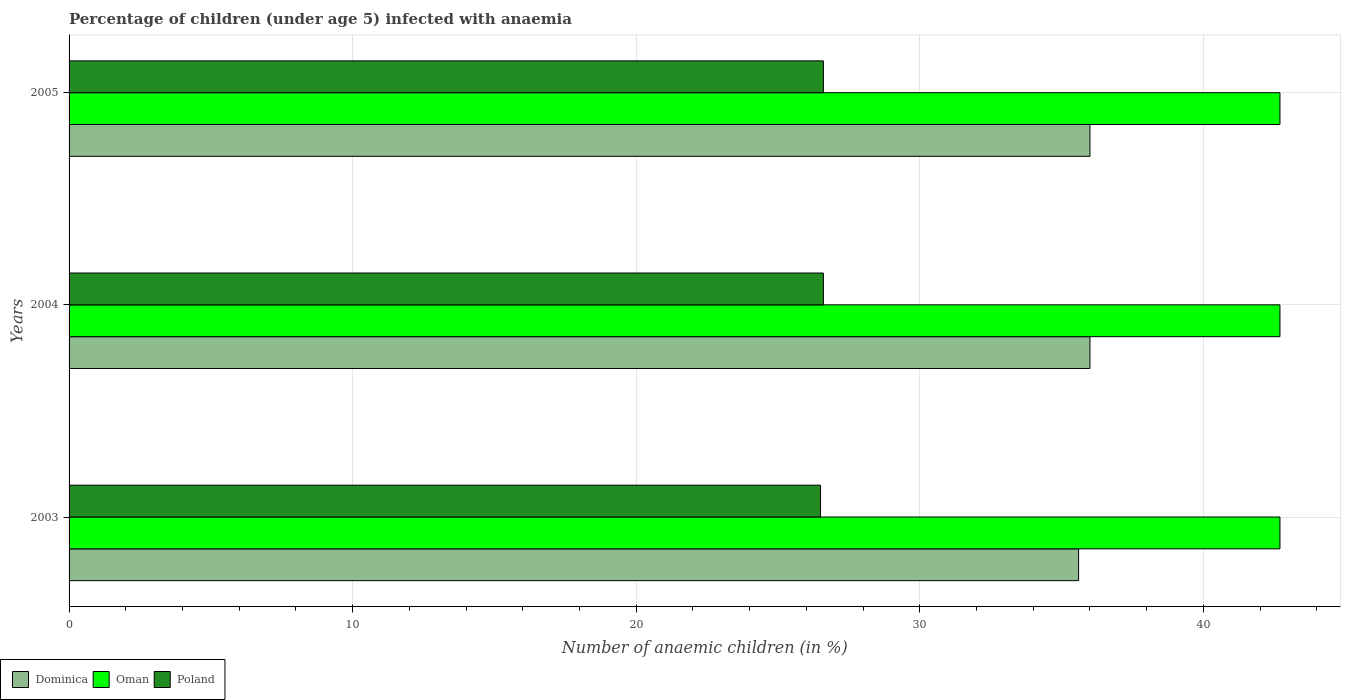Are the number of bars per tick equal to the number of legend labels?
Ensure brevity in your answer.  Yes. How many bars are there on the 3rd tick from the bottom?
Your response must be concise. 3. What is the label of the 3rd group of bars from the top?
Offer a terse response. 2003. In how many cases, is the number of bars for a given year not equal to the number of legend labels?
Provide a succinct answer. 0. Across all years, what is the maximum percentage of children infected with anaemia in in Oman?
Make the answer very short. 42.7. In which year was the percentage of children infected with anaemia in in Poland minimum?
Offer a terse response. 2003. What is the total percentage of children infected with anaemia in in Poland in the graph?
Your answer should be compact. 79.7. What is the difference between the percentage of children infected with anaemia in in Poland in 2003 and that in 2005?
Your answer should be very brief. -0.1. What is the difference between the percentage of children infected with anaemia in in Poland in 2005 and the percentage of children infected with anaemia in in Oman in 2003?
Provide a short and direct response. -16.1. What is the average percentage of children infected with anaemia in in Oman per year?
Make the answer very short. 42.7. In how many years, is the percentage of children infected with anaemia in in Dominica greater than 12 %?
Your response must be concise. 3. What is the ratio of the percentage of children infected with anaemia in in Dominica in 2003 to that in 2004?
Provide a succinct answer. 0.99. Is the percentage of children infected with anaemia in in Poland in 2003 less than that in 2004?
Make the answer very short. Yes. Is the difference between the percentage of children infected with anaemia in in Oman in 2003 and 2004 greater than the difference between the percentage of children infected with anaemia in in Poland in 2003 and 2004?
Your answer should be compact. Yes. In how many years, is the percentage of children infected with anaemia in in Oman greater than the average percentage of children infected with anaemia in in Oman taken over all years?
Offer a terse response. 0. What does the 2nd bar from the bottom in 2003 represents?
Keep it short and to the point. Oman. Is it the case that in every year, the sum of the percentage of children infected with anaemia in in Oman and percentage of children infected with anaemia in in Poland is greater than the percentage of children infected with anaemia in in Dominica?
Provide a succinct answer. Yes. How many bars are there?
Provide a succinct answer. 9. Are all the bars in the graph horizontal?
Offer a very short reply. Yes. Does the graph contain grids?
Provide a succinct answer. Yes. How many legend labels are there?
Keep it short and to the point. 3. What is the title of the graph?
Offer a very short reply. Percentage of children (under age 5) infected with anaemia. What is the label or title of the X-axis?
Offer a terse response. Number of anaemic children (in %). What is the Number of anaemic children (in %) of Dominica in 2003?
Provide a succinct answer. 35.6. What is the Number of anaemic children (in %) in Oman in 2003?
Your answer should be compact. 42.7. What is the Number of anaemic children (in %) in Poland in 2003?
Ensure brevity in your answer.  26.5. What is the Number of anaemic children (in %) in Oman in 2004?
Keep it short and to the point. 42.7. What is the Number of anaemic children (in %) in Poland in 2004?
Make the answer very short. 26.6. What is the Number of anaemic children (in %) in Dominica in 2005?
Offer a terse response. 36. What is the Number of anaemic children (in %) of Oman in 2005?
Your answer should be compact. 42.7. What is the Number of anaemic children (in %) of Poland in 2005?
Keep it short and to the point. 26.6. Across all years, what is the maximum Number of anaemic children (in %) of Oman?
Provide a short and direct response. 42.7. Across all years, what is the maximum Number of anaemic children (in %) of Poland?
Make the answer very short. 26.6. Across all years, what is the minimum Number of anaemic children (in %) of Dominica?
Offer a terse response. 35.6. Across all years, what is the minimum Number of anaemic children (in %) of Oman?
Your response must be concise. 42.7. What is the total Number of anaemic children (in %) of Dominica in the graph?
Provide a short and direct response. 107.6. What is the total Number of anaemic children (in %) of Oman in the graph?
Your answer should be very brief. 128.1. What is the total Number of anaemic children (in %) in Poland in the graph?
Give a very brief answer. 79.7. What is the difference between the Number of anaemic children (in %) of Dominica in 2003 and that in 2005?
Make the answer very short. -0.4. What is the difference between the Number of anaemic children (in %) of Poland in 2003 and that in 2005?
Ensure brevity in your answer.  -0.1. What is the difference between the Number of anaemic children (in %) in Oman in 2004 and that in 2005?
Your answer should be very brief. 0. What is the difference between the Number of anaemic children (in %) in Poland in 2004 and that in 2005?
Provide a succinct answer. 0. What is the difference between the Number of anaemic children (in %) of Dominica in 2003 and the Number of anaemic children (in %) of Oman in 2004?
Provide a short and direct response. -7.1. What is the difference between the Number of anaemic children (in %) in Dominica in 2003 and the Number of anaemic children (in %) in Oman in 2005?
Offer a very short reply. -7.1. What is the difference between the Number of anaemic children (in %) of Dominica in 2004 and the Number of anaemic children (in %) of Oman in 2005?
Provide a succinct answer. -6.7. What is the difference between the Number of anaemic children (in %) of Dominica in 2004 and the Number of anaemic children (in %) of Poland in 2005?
Ensure brevity in your answer.  9.4. What is the average Number of anaemic children (in %) in Dominica per year?
Your answer should be compact. 35.87. What is the average Number of anaemic children (in %) of Oman per year?
Your answer should be very brief. 42.7. What is the average Number of anaemic children (in %) in Poland per year?
Provide a succinct answer. 26.57. In the year 2003, what is the difference between the Number of anaemic children (in %) in Dominica and Number of anaemic children (in %) in Oman?
Provide a succinct answer. -7.1. In the year 2004, what is the difference between the Number of anaemic children (in %) of Dominica and Number of anaemic children (in %) of Oman?
Ensure brevity in your answer.  -6.7. In the year 2005, what is the difference between the Number of anaemic children (in %) of Oman and Number of anaemic children (in %) of Poland?
Give a very brief answer. 16.1. What is the ratio of the Number of anaemic children (in %) in Dominica in 2003 to that in 2004?
Offer a very short reply. 0.99. What is the ratio of the Number of anaemic children (in %) of Poland in 2003 to that in 2004?
Provide a short and direct response. 1. What is the ratio of the Number of anaemic children (in %) of Dominica in 2003 to that in 2005?
Offer a very short reply. 0.99. What is the ratio of the Number of anaemic children (in %) of Dominica in 2004 to that in 2005?
Offer a very short reply. 1. What is the ratio of the Number of anaemic children (in %) in Poland in 2004 to that in 2005?
Your response must be concise. 1. What is the difference between the highest and the second highest Number of anaemic children (in %) of Poland?
Your response must be concise. 0. What is the difference between the highest and the lowest Number of anaemic children (in %) in Dominica?
Your response must be concise. 0.4. What is the difference between the highest and the lowest Number of anaemic children (in %) in Oman?
Provide a short and direct response. 0. What is the difference between the highest and the lowest Number of anaemic children (in %) in Poland?
Keep it short and to the point. 0.1. 